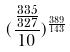<formula> <loc_0><loc_0><loc_500><loc_500>( \frac { \frac { 3 3 5 } { 3 2 7 } } { 1 0 } ) ^ { \frac { 3 8 9 } { 1 4 3 } }</formula> 